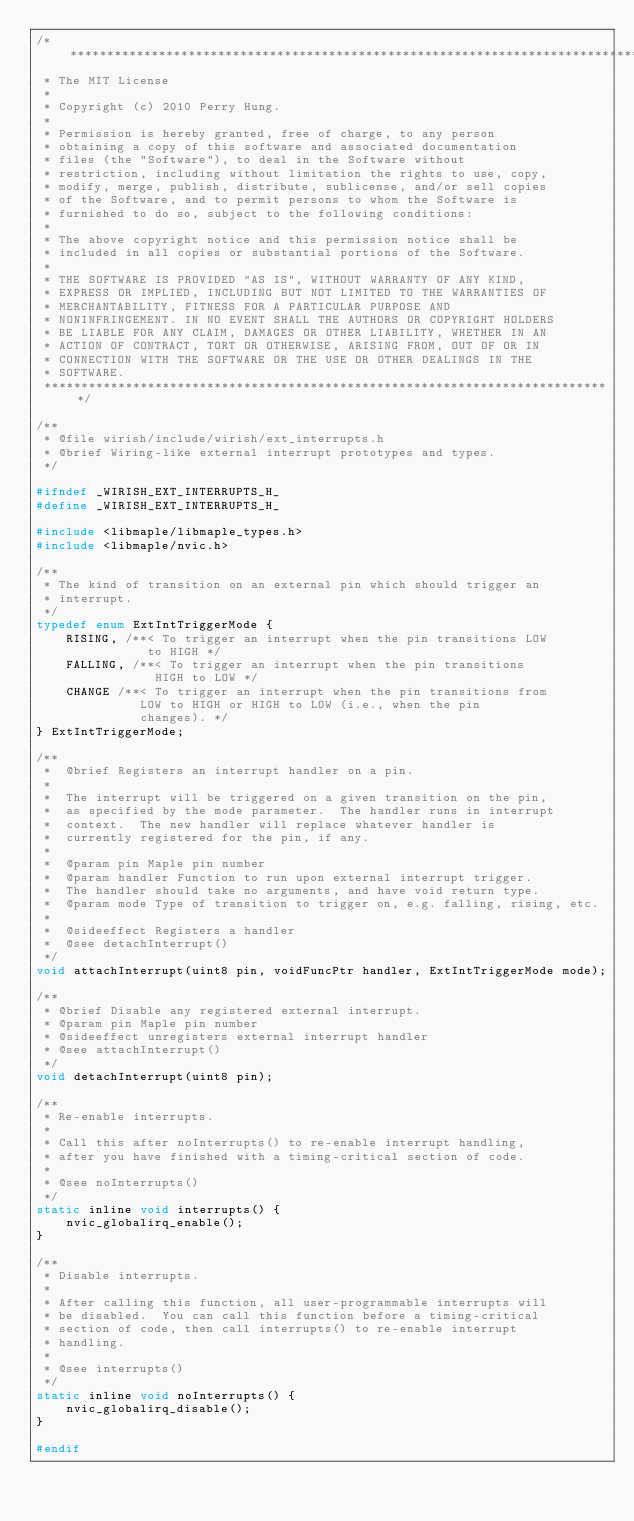Convert code to text. <code><loc_0><loc_0><loc_500><loc_500><_C_>/******************************************************************************
 * The MIT License
 *
 * Copyright (c) 2010 Perry Hung.
 *
 * Permission is hereby granted, free of charge, to any person
 * obtaining a copy of this software and associated documentation
 * files (the "Software"), to deal in the Software without
 * restriction, including without limitation the rights to use, copy,
 * modify, merge, publish, distribute, sublicense, and/or sell copies
 * of the Software, and to permit persons to whom the Software is
 * furnished to do so, subject to the following conditions:
 *
 * The above copyright notice and this permission notice shall be
 * included in all copies or substantial portions of the Software.
 *
 * THE SOFTWARE IS PROVIDED "AS IS", WITHOUT WARRANTY OF ANY KIND,
 * EXPRESS OR IMPLIED, INCLUDING BUT NOT LIMITED TO THE WARRANTIES OF
 * MERCHANTABILITY, FITNESS FOR A PARTICULAR PURPOSE AND
 * NONINFRINGEMENT. IN NO EVENT SHALL THE AUTHORS OR COPYRIGHT HOLDERS
 * BE LIABLE FOR ANY CLAIM, DAMAGES OR OTHER LIABILITY, WHETHER IN AN
 * ACTION OF CONTRACT, TORT OR OTHERWISE, ARISING FROM, OUT OF OR IN
 * CONNECTION WITH THE SOFTWARE OR THE USE OR OTHER DEALINGS IN THE
 * SOFTWARE.
 *****************************************************************************/

/**
 * @file wirish/include/wirish/ext_interrupts.h
 * @brief Wiring-like external interrupt prototypes and types.
 */

#ifndef _WIRISH_EXT_INTERRUPTS_H_
#define _WIRISH_EXT_INTERRUPTS_H_

#include <libmaple/libmaple_types.h>
#include <libmaple/nvic.h>

/**
 * The kind of transition on an external pin which should trigger an
 * interrupt.
 */
typedef enum ExtIntTriggerMode {
    RISING, /**< To trigger an interrupt when the pin transitions LOW
               to HIGH */
    FALLING, /**< To trigger an interrupt when the pin transitions
                HIGH to LOW */
    CHANGE /**< To trigger an interrupt when the pin transitions from
              LOW to HIGH or HIGH to LOW (i.e., when the pin
              changes). */
} ExtIntTriggerMode;

/**
 *  @brief Registers an interrupt handler on a pin.
 *
 *  The interrupt will be triggered on a given transition on the pin,
 *  as specified by the mode parameter.  The handler runs in interrupt
 *  context.  The new handler will replace whatever handler is
 *  currently registered for the pin, if any.
 *
 *  @param pin Maple pin number
 *  @param handler Function to run upon external interrupt trigger.
 *  The handler should take no arguments, and have void return type.
 *  @param mode Type of transition to trigger on, e.g. falling, rising, etc.
 *
 *  @sideeffect Registers a handler
 *  @see detachInterrupt()
 */
void attachInterrupt(uint8 pin, voidFuncPtr handler, ExtIntTriggerMode mode);

/**
 * @brief Disable any registered external interrupt.
 * @param pin Maple pin number
 * @sideeffect unregisters external interrupt handler
 * @see attachInterrupt()
 */
void detachInterrupt(uint8 pin);

/**
 * Re-enable interrupts.
 *
 * Call this after noInterrupts() to re-enable interrupt handling,
 * after you have finished with a timing-critical section of code.
 *
 * @see noInterrupts()
 */
static inline void interrupts() {
    nvic_globalirq_enable();
}

/**
 * Disable interrupts.
 *
 * After calling this function, all user-programmable interrupts will
 * be disabled.  You can call this function before a timing-critical
 * section of code, then call interrupts() to re-enable interrupt
 * handling.
 *
 * @see interrupts()
 */
static inline void noInterrupts() {
    nvic_globalirq_disable();
}

#endif

</code> 